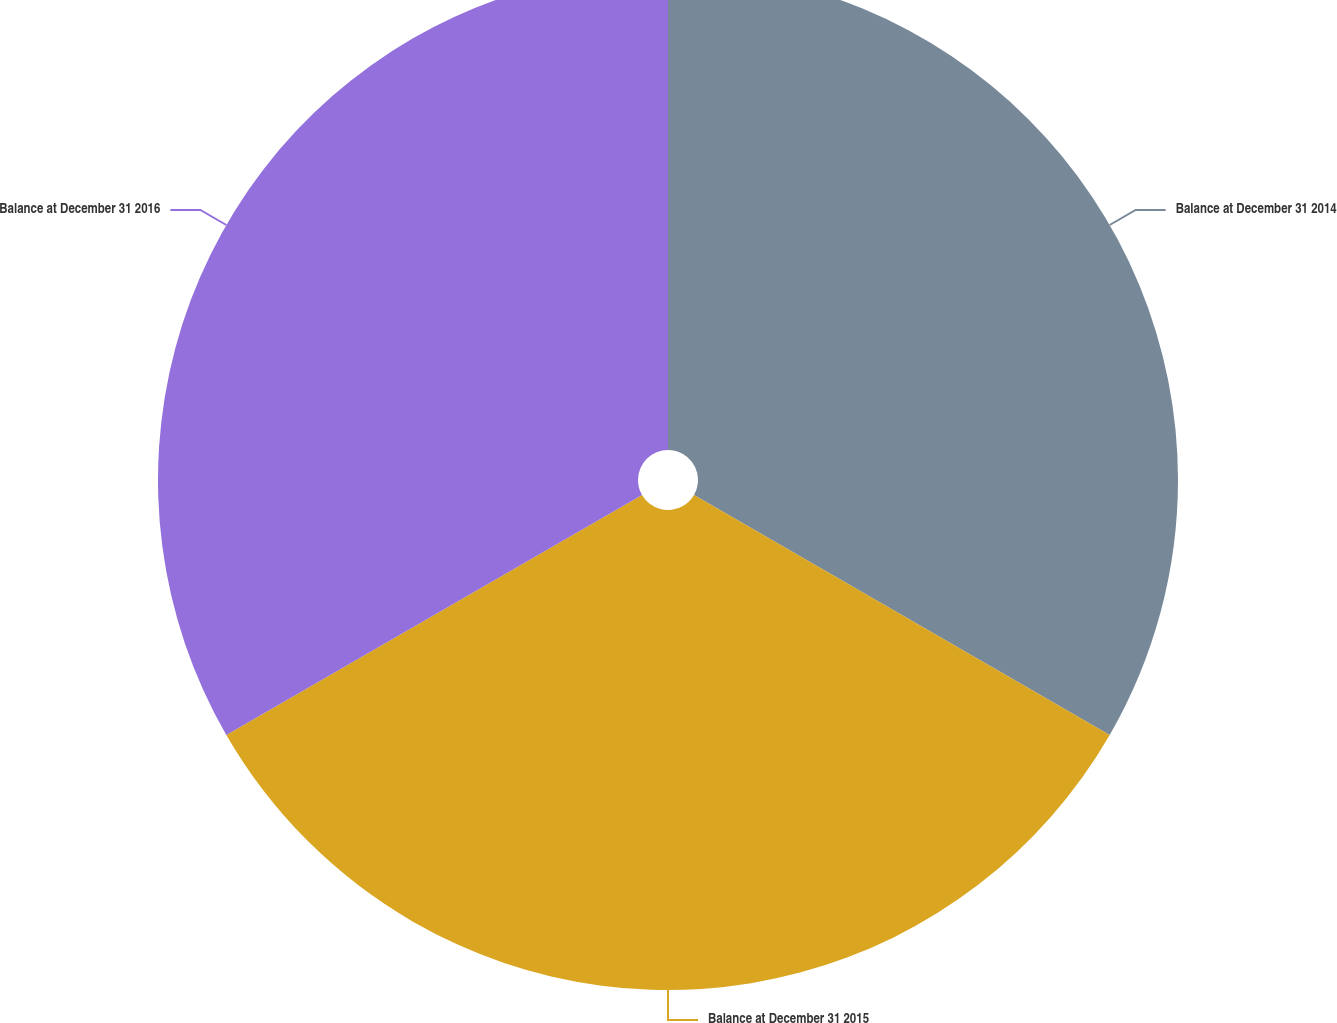Convert chart. <chart><loc_0><loc_0><loc_500><loc_500><pie_chart><fcel>Balance at December 31 2014<fcel>Balance at December 31 2015<fcel>Balance at December 31 2016<nl><fcel>33.33%<fcel>33.33%<fcel>33.33%<nl></chart> 